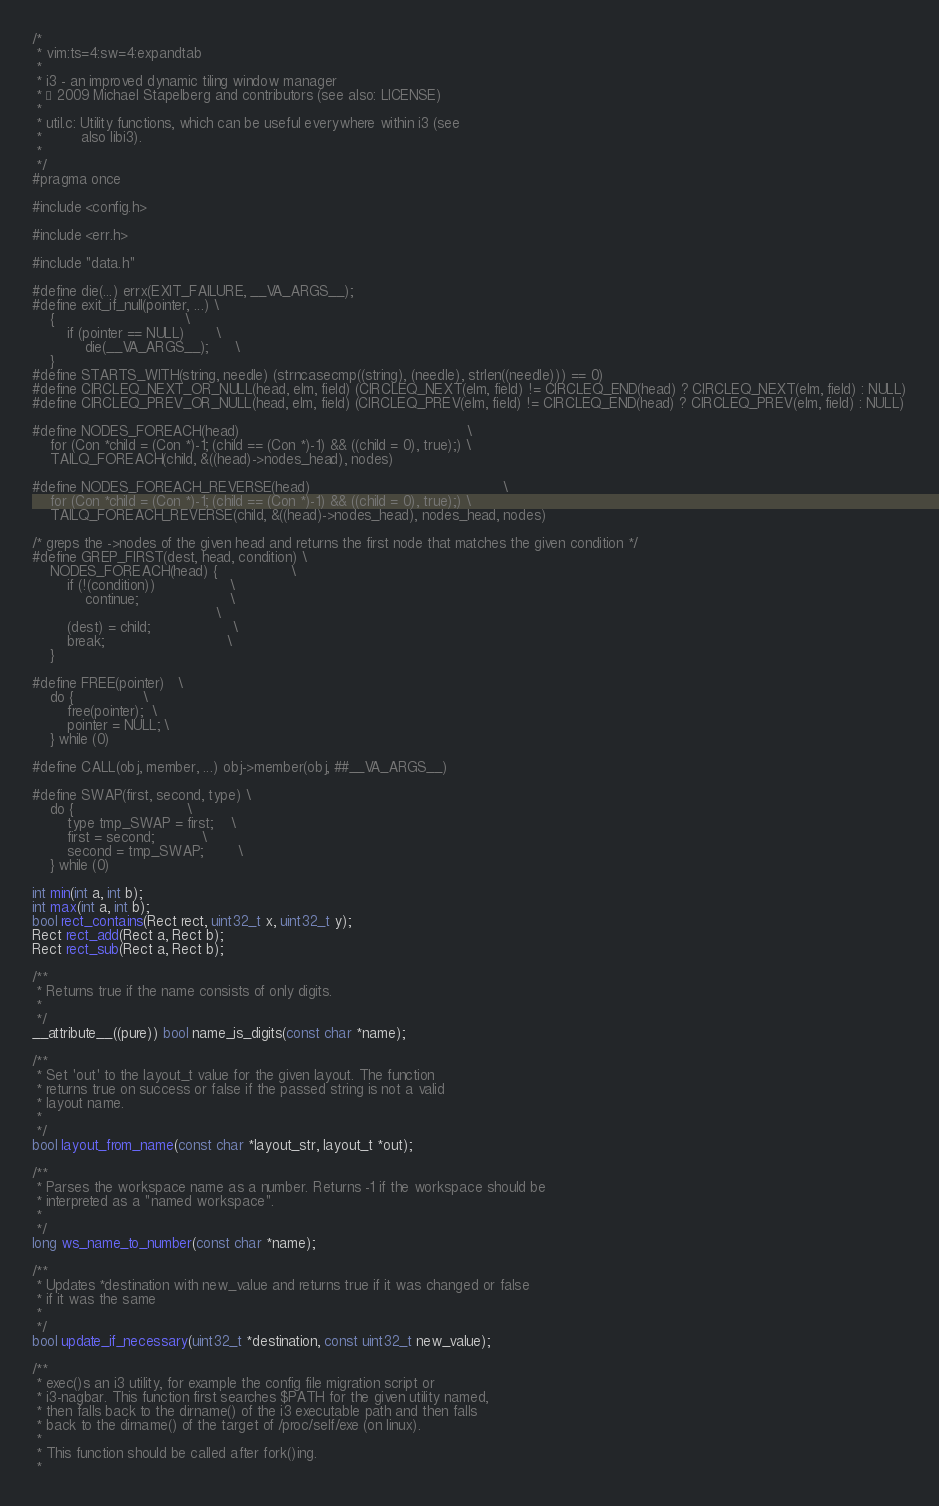Convert code to text. <code><loc_0><loc_0><loc_500><loc_500><_C_>/*
 * vim:ts=4:sw=4:expandtab
 *
 * i3 - an improved dynamic tiling window manager
 * © 2009 Michael Stapelberg and contributors (see also: LICENSE)
 *
 * util.c: Utility functions, which can be useful everywhere within i3 (see
 *         also libi3).
 *
 */
#pragma once

#include <config.h>

#include <err.h>

#include "data.h"

#define die(...) errx(EXIT_FAILURE, __VA_ARGS__);
#define exit_if_null(pointer, ...) \
    {                              \
        if (pointer == NULL)       \
            die(__VA_ARGS__);      \
    }
#define STARTS_WITH(string, needle) (strncasecmp((string), (needle), strlen((needle))) == 0)
#define CIRCLEQ_NEXT_OR_NULL(head, elm, field) (CIRCLEQ_NEXT(elm, field) != CIRCLEQ_END(head) ? CIRCLEQ_NEXT(elm, field) : NULL)
#define CIRCLEQ_PREV_OR_NULL(head, elm, field) (CIRCLEQ_PREV(elm, field) != CIRCLEQ_END(head) ? CIRCLEQ_PREV(elm, field) : NULL)

#define NODES_FOREACH(head)                                                    \
    for (Con *child = (Con *)-1; (child == (Con *)-1) && ((child = 0), true);) \
    TAILQ_FOREACH(child, &((head)->nodes_head), nodes)

#define NODES_FOREACH_REVERSE(head)                                            \
    for (Con *child = (Con *)-1; (child == (Con *)-1) && ((child = 0), true);) \
    TAILQ_FOREACH_REVERSE(child, &((head)->nodes_head), nodes_head, nodes)

/* greps the ->nodes of the given head and returns the first node that matches the given condition */
#define GREP_FIRST(dest, head, condition) \
    NODES_FOREACH(head) {                 \
        if (!(condition))                 \
            continue;                     \
                                          \
        (dest) = child;                   \
        break;                            \
    }

#define FREE(pointer)   \
    do {                \
        free(pointer);  \
        pointer = NULL; \
    } while (0)

#define CALL(obj, member, ...) obj->member(obj, ##__VA_ARGS__)

#define SWAP(first, second, type) \
    do {                          \
        type tmp_SWAP = first;    \
        first = second;           \
        second = tmp_SWAP;        \
    } while (0)

int min(int a, int b);
int max(int a, int b);
bool rect_contains(Rect rect, uint32_t x, uint32_t y);
Rect rect_add(Rect a, Rect b);
Rect rect_sub(Rect a, Rect b);

/**
 * Returns true if the name consists of only digits.
 *
 */
__attribute__((pure)) bool name_is_digits(const char *name);

/**
 * Set 'out' to the layout_t value for the given layout. The function
 * returns true on success or false if the passed string is not a valid
 * layout name.
 *
 */
bool layout_from_name(const char *layout_str, layout_t *out);

/**
 * Parses the workspace name as a number. Returns -1 if the workspace should be
 * interpreted as a "named workspace".
 *
 */
long ws_name_to_number(const char *name);

/**
 * Updates *destination with new_value and returns true if it was changed or false
 * if it was the same
 *
 */
bool update_if_necessary(uint32_t *destination, const uint32_t new_value);

/**
 * exec()s an i3 utility, for example the config file migration script or
 * i3-nagbar. This function first searches $PATH for the given utility named,
 * then falls back to the dirname() of the i3 executable path and then falls
 * back to the dirname() of the target of /proc/self/exe (on linux).
 *
 * This function should be called after fork()ing.
 *</code> 